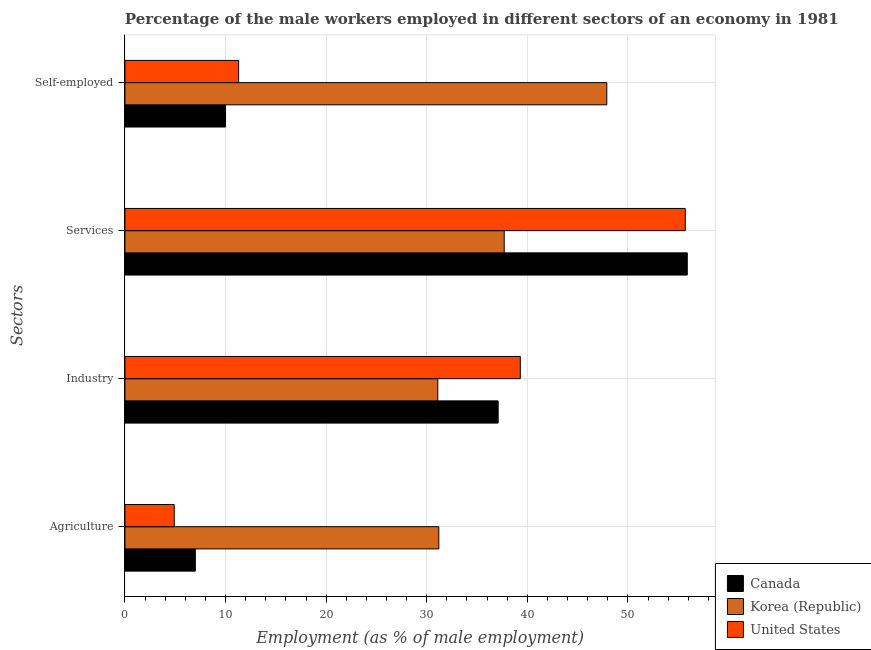How many different coloured bars are there?
Keep it short and to the point. 3. Are the number of bars per tick equal to the number of legend labels?
Your response must be concise. Yes. What is the label of the 4th group of bars from the top?
Offer a terse response. Agriculture. What is the percentage of male workers in agriculture in United States?
Keep it short and to the point. 4.9. Across all countries, what is the maximum percentage of male workers in industry?
Keep it short and to the point. 39.3. Across all countries, what is the minimum percentage of male workers in agriculture?
Your response must be concise. 4.9. In which country was the percentage of male workers in agriculture maximum?
Your answer should be compact. Korea (Republic). What is the total percentage of self employed male workers in the graph?
Provide a succinct answer. 69.2. What is the difference between the percentage of male workers in industry in Canada and that in Korea (Republic)?
Give a very brief answer. 6. What is the difference between the percentage of male workers in agriculture in Korea (Republic) and the percentage of male workers in industry in Canada?
Offer a terse response. -5.9. What is the average percentage of male workers in agriculture per country?
Keep it short and to the point. 14.37. What is the difference between the percentage of self employed male workers and percentage of male workers in industry in Korea (Republic)?
Offer a terse response. 16.8. What is the ratio of the percentage of male workers in industry in United States to that in Korea (Republic)?
Provide a short and direct response. 1.26. What is the difference between the highest and the second highest percentage of male workers in industry?
Your answer should be compact. 2.2. What is the difference between the highest and the lowest percentage of male workers in services?
Offer a terse response. 18.2. Is the sum of the percentage of male workers in services in Canada and United States greater than the maximum percentage of self employed male workers across all countries?
Make the answer very short. Yes. What does the 1st bar from the top in Industry represents?
Give a very brief answer. United States. Is it the case that in every country, the sum of the percentage of male workers in agriculture and percentage of male workers in industry is greater than the percentage of male workers in services?
Provide a succinct answer. No. Are all the bars in the graph horizontal?
Your answer should be compact. Yes. What is the difference between two consecutive major ticks on the X-axis?
Offer a terse response. 10. Are the values on the major ticks of X-axis written in scientific E-notation?
Provide a short and direct response. No. Where does the legend appear in the graph?
Provide a succinct answer. Bottom right. How many legend labels are there?
Keep it short and to the point. 3. What is the title of the graph?
Your response must be concise. Percentage of the male workers employed in different sectors of an economy in 1981. What is the label or title of the X-axis?
Offer a terse response. Employment (as % of male employment). What is the label or title of the Y-axis?
Ensure brevity in your answer.  Sectors. What is the Employment (as % of male employment) of Canada in Agriculture?
Ensure brevity in your answer.  7. What is the Employment (as % of male employment) in Korea (Republic) in Agriculture?
Offer a terse response. 31.2. What is the Employment (as % of male employment) in United States in Agriculture?
Keep it short and to the point. 4.9. What is the Employment (as % of male employment) in Canada in Industry?
Offer a terse response. 37.1. What is the Employment (as % of male employment) in Korea (Republic) in Industry?
Your answer should be compact. 31.1. What is the Employment (as % of male employment) in United States in Industry?
Your response must be concise. 39.3. What is the Employment (as % of male employment) of Canada in Services?
Your response must be concise. 55.9. What is the Employment (as % of male employment) of Korea (Republic) in Services?
Offer a very short reply. 37.7. What is the Employment (as % of male employment) in United States in Services?
Offer a terse response. 55.7. What is the Employment (as % of male employment) in Canada in Self-employed?
Ensure brevity in your answer.  10. What is the Employment (as % of male employment) in Korea (Republic) in Self-employed?
Make the answer very short. 47.9. What is the Employment (as % of male employment) in United States in Self-employed?
Offer a very short reply. 11.3. Across all Sectors, what is the maximum Employment (as % of male employment) in Canada?
Offer a terse response. 55.9. Across all Sectors, what is the maximum Employment (as % of male employment) of Korea (Republic)?
Your response must be concise. 47.9. Across all Sectors, what is the maximum Employment (as % of male employment) in United States?
Offer a terse response. 55.7. Across all Sectors, what is the minimum Employment (as % of male employment) in Korea (Republic)?
Your answer should be very brief. 31.1. Across all Sectors, what is the minimum Employment (as % of male employment) in United States?
Provide a short and direct response. 4.9. What is the total Employment (as % of male employment) of Canada in the graph?
Keep it short and to the point. 110. What is the total Employment (as % of male employment) of Korea (Republic) in the graph?
Ensure brevity in your answer.  147.9. What is the total Employment (as % of male employment) of United States in the graph?
Keep it short and to the point. 111.2. What is the difference between the Employment (as % of male employment) of Canada in Agriculture and that in Industry?
Provide a short and direct response. -30.1. What is the difference between the Employment (as % of male employment) in Korea (Republic) in Agriculture and that in Industry?
Offer a very short reply. 0.1. What is the difference between the Employment (as % of male employment) of United States in Agriculture and that in Industry?
Keep it short and to the point. -34.4. What is the difference between the Employment (as % of male employment) of Canada in Agriculture and that in Services?
Your answer should be compact. -48.9. What is the difference between the Employment (as % of male employment) of United States in Agriculture and that in Services?
Offer a very short reply. -50.8. What is the difference between the Employment (as % of male employment) in Korea (Republic) in Agriculture and that in Self-employed?
Keep it short and to the point. -16.7. What is the difference between the Employment (as % of male employment) of United States in Agriculture and that in Self-employed?
Provide a short and direct response. -6.4. What is the difference between the Employment (as % of male employment) in Canada in Industry and that in Services?
Ensure brevity in your answer.  -18.8. What is the difference between the Employment (as % of male employment) of United States in Industry and that in Services?
Make the answer very short. -16.4. What is the difference between the Employment (as % of male employment) of Canada in Industry and that in Self-employed?
Your response must be concise. 27.1. What is the difference between the Employment (as % of male employment) of Korea (Republic) in Industry and that in Self-employed?
Your response must be concise. -16.8. What is the difference between the Employment (as % of male employment) in Canada in Services and that in Self-employed?
Give a very brief answer. 45.9. What is the difference between the Employment (as % of male employment) of Korea (Republic) in Services and that in Self-employed?
Keep it short and to the point. -10.2. What is the difference between the Employment (as % of male employment) of United States in Services and that in Self-employed?
Keep it short and to the point. 44.4. What is the difference between the Employment (as % of male employment) of Canada in Agriculture and the Employment (as % of male employment) of Korea (Republic) in Industry?
Provide a short and direct response. -24.1. What is the difference between the Employment (as % of male employment) in Canada in Agriculture and the Employment (as % of male employment) in United States in Industry?
Provide a short and direct response. -32.3. What is the difference between the Employment (as % of male employment) of Korea (Republic) in Agriculture and the Employment (as % of male employment) of United States in Industry?
Offer a terse response. -8.1. What is the difference between the Employment (as % of male employment) of Canada in Agriculture and the Employment (as % of male employment) of Korea (Republic) in Services?
Provide a short and direct response. -30.7. What is the difference between the Employment (as % of male employment) in Canada in Agriculture and the Employment (as % of male employment) in United States in Services?
Ensure brevity in your answer.  -48.7. What is the difference between the Employment (as % of male employment) of Korea (Republic) in Agriculture and the Employment (as % of male employment) of United States in Services?
Give a very brief answer. -24.5. What is the difference between the Employment (as % of male employment) in Canada in Agriculture and the Employment (as % of male employment) in Korea (Republic) in Self-employed?
Offer a very short reply. -40.9. What is the difference between the Employment (as % of male employment) in Canada in Agriculture and the Employment (as % of male employment) in United States in Self-employed?
Offer a very short reply. -4.3. What is the difference between the Employment (as % of male employment) of Korea (Republic) in Agriculture and the Employment (as % of male employment) of United States in Self-employed?
Your answer should be very brief. 19.9. What is the difference between the Employment (as % of male employment) in Canada in Industry and the Employment (as % of male employment) in Korea (Republic) in Services?
Provide a succinct answer. -0.6. What is the difference between the Employment (as % of male employment) in Canada in Industry and the Employment (as % of male employment) in United States in Services?
Keep it short and to the point. -18.6. What is the difference between the Employment (as % of male employment) in Korea (Republic) in Industry and the Employment (as % of male employment) in United States in Services?
Ensure brevity in your answer.  -24.6. What is the difference between the Employment (as % of male employment) in Canada in Industry and the Employment (as % of male employment) in Korea (Republic) in Self-employed?
Offer a terse response. -10.8. What is the difference between the Employment (as % of male employment) of Canada in Industry and the Employment (as % of male employment) of United States in Self-employed?
Provide a short and direct response. 25.8. What is the difference between the Employment (as % of male employment) of Korea (Republic) in Industry and the Employment (as % of male employment) of United States in Self-employed?
Ensure brevity in your answer.  19.8. What is the difference between the Employment (as % of male employment) in Canada in Services and the Employment (as % of male employment) in United States in Self-employed?
Keep it short and to the point. 44.6. What is the difference between the Employment (as % of male employment) of Korea (Republic) in Services and the Employment (as % of male employment) of United States in Self-employed?
Offer a very short reply. 26.4. What is the average Employment (as % of male employment) of Korea (Republic) per Sectors?
Make the answer very short. 36.98. What is the average Employment (as % of male employment) of United States per Sectors?
Your answer should be compact. 27.8. What is the difference between the Employment (as % of male employment) of Canada and Employment (as % of male employment) of Korea (Republic) in Agriculture?
Offer a very short reply. -24.2. What is the difference between the Employment (as % of male employment) in Korea (Republic) and Employment (as % of male employment) in United States in Agriculture?
Provide a short and direct response. 26.3. What is the difference between the Employment (as % of male employment) in Canada and Employment (as % of male employment) in United States in Industry?
Your response must be concise. -2.2. What is the difference between the Employment (as % of male employment) of Canada and Employment (as % of male employment) of Korea (Republic) in Self-employed?
Your answer should be very brief. -37.9. What is the difference between the Employment (as % of male employment) of Canada and Employment (as % of male employment) of United States in Self-employed?
Provide a succinct answer. -1.3. What is the difference between the Employment (as % of male employment) of Korea (Republic) and Employment (as % of male employment) of United States in Self-employed?
Provide a succinct answer. 36.6. What is the ratio of the Employment (as % of male employment) of Canada in Agriculture to that in Industry?
Your answer should be compact. 0.19. What is the ratio of the Employment (as % of male employment) of Korea (Republic) in Agriculture to that in Industry?
Offer a terse response. 1. What is the ratio of the Employment (as % of male employment) of United States in Agriculture to that in Industry?
Make the answer very short. 0.12. What is the ratio of the Employment (as % of male employment) of Canada in Agriculture to that in Services?
Offer a very short reply. 0.13. What is the ratio of the Employment (as % of male employment) of Korea (Republic) in Agriculture to that in Services?
Provide a short and direct response. 0.83. What is the ratio of the Employment (as % of male employment) in United States in Agriculture to that in Services?
Make the answer very short. 0.09. What is the ratio of the Employment (as % of male employment) of Korea (Republic) in Agriculture to that in Self-employed?
Keep it short and to the point. 0.65. What is the ratio of the Employment (as % of male employment) of United States in Agriculture to that in Self-employed?
Your response must be concise. 0.43. What is the ratio of the Employment (as % of male employment) of Canada in Industry to that in Services?
Your answer should be compact. 0.66. What is the ratio of the Employment (as % of male employment) of Korea (Republic) in Industry to that in Services?
Provide a short and direct response. 0.82. What is the ratio of the Employment (as % of male employment) in United States in Industry to that in Services?
Provide a short and direct response. 0.71. What is the ratio of the Employment (as % of male employment) in Canada in Industry to that in Self-employed?
Give a very brief answer. 3.71. What is the ratio of the Employment (as % of male employment) in Korea (Republic) in Industry to that in Self-employed?
Your response must be concise. 0.65. What is the ratio of the Employment (as % of male employment) of United States in Industry to that in Self-employed?
Provide a succinct answer. 3.48. What is the ratio of the Employment (as % of male employment) of Canada in Services to that in Self-employed?
Provide a short and direct response. 5.59. What is the ratio of the Employment (as % of male employment) of Korea (Republic) in Services to that in Self-employed?
Give a very brief answer. 0.79. What is the ratio of the Employment (as % of male employment) in United States in Services to that in Self-employed?
Provide a short and direct response. 4.93. What is the difference between the highest and the second highest Employment (as % of male employment) in Canada?
Give a very brief answer. 18.8. What is the difference between the highest and the lowest Employment (as % of male employment) of Canada?
Your answer should be very brief. 48.9. What is the difference between the highest and the lowest Employment (as % of male employment) of Korea (Republic)?
Provide a succinct answer. 16.8. What is the difference between the highest and the lowest Employment (as % of male employment) of United States?
Offer a very short reply. 50.8. 